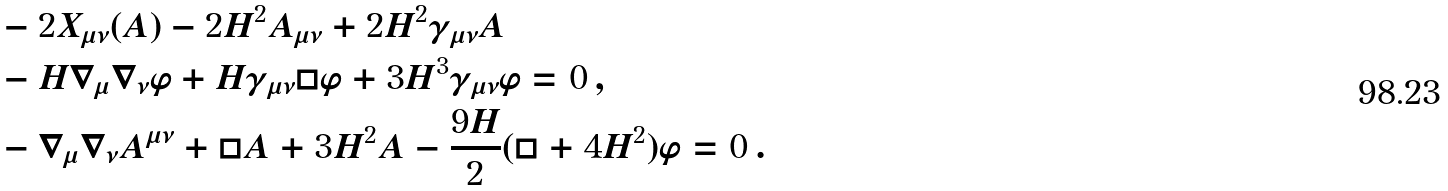<formula> <loc_0><loc_0><loc_500><loc_500>& - 2 X _ { \mu \nu } ( A ) - 2 H ^ { 2 } A _ { \mu \nu } + 2 H ^ { 2 } \gamma _ { \mu \nu } A \\ & - H \nabla _ { \mu } \nabla _ { \nu } \varphi + H \gamma _ { \mu \nu } \Box \varphi + 3 H ^ { 3 } \gamma _ { \mu \nu } \varphi = 0 \, , \\ & - \nabla _ { \mu } \nabla _ { \nu } A ^ { \mu \nu } + \Box A + 3 H ^ { 2 } A - \frac { 9 H } { 2 } ( \Box + 4 H ^ { 2 } ) \varphi = 0 \, .</formula> 